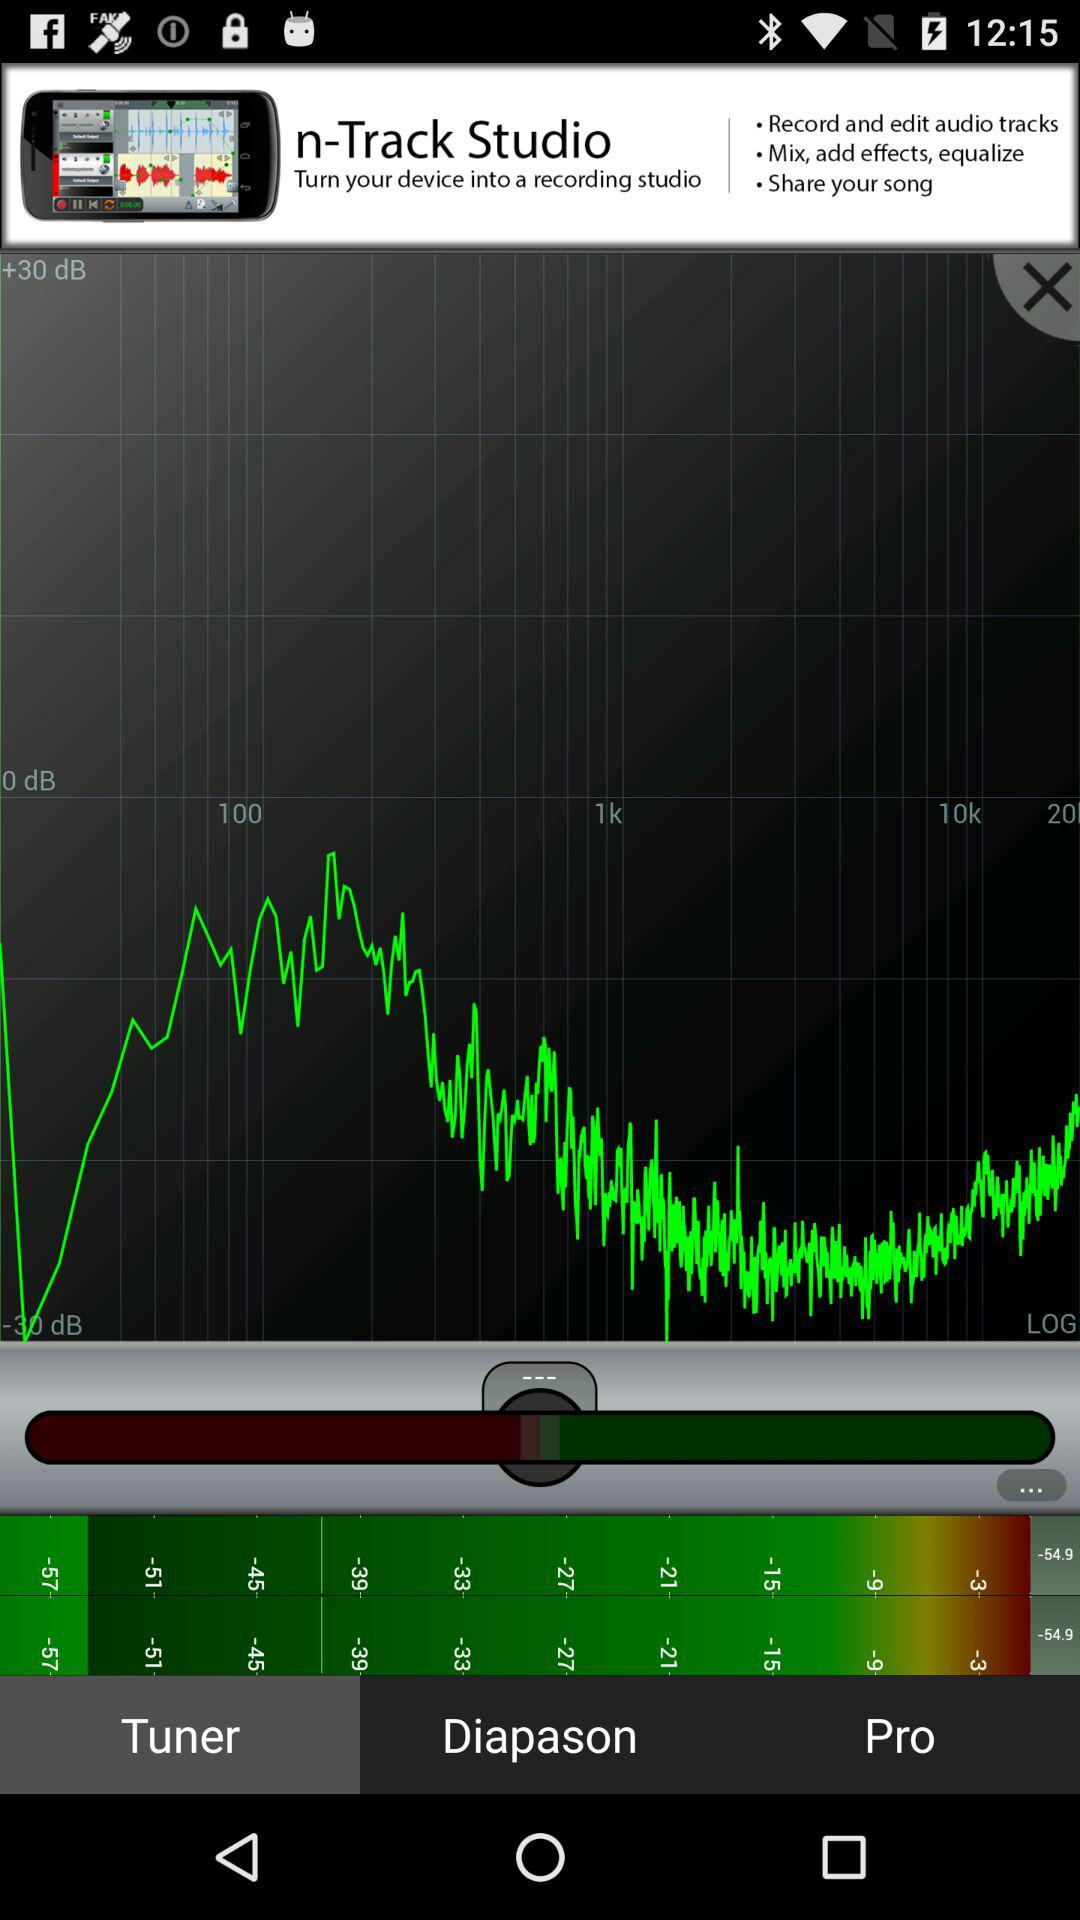What is the version number of "n-Track Studio"?
When the provided information is insufficient, respond with <no answer>. <no answer> 